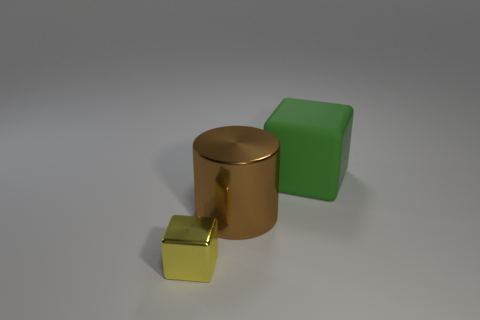What materials appear to be represented in this image? The three objects in the image seem to represent different materials. The largest, a cylinder, has a metallic finish suggestive of bronze or copper. The cube in the center has a matte surface, resembling a green rubber. Lastly, the smallest object in the foreground appears to have a shiny, reflective surface, likely to be a representation of polished gold. 